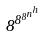<formula> <loc_0><loc_0><loc_500><loc_500>8 ^ { 8 ^ { 8 ^ { n ^ { h } } } }</formula> 